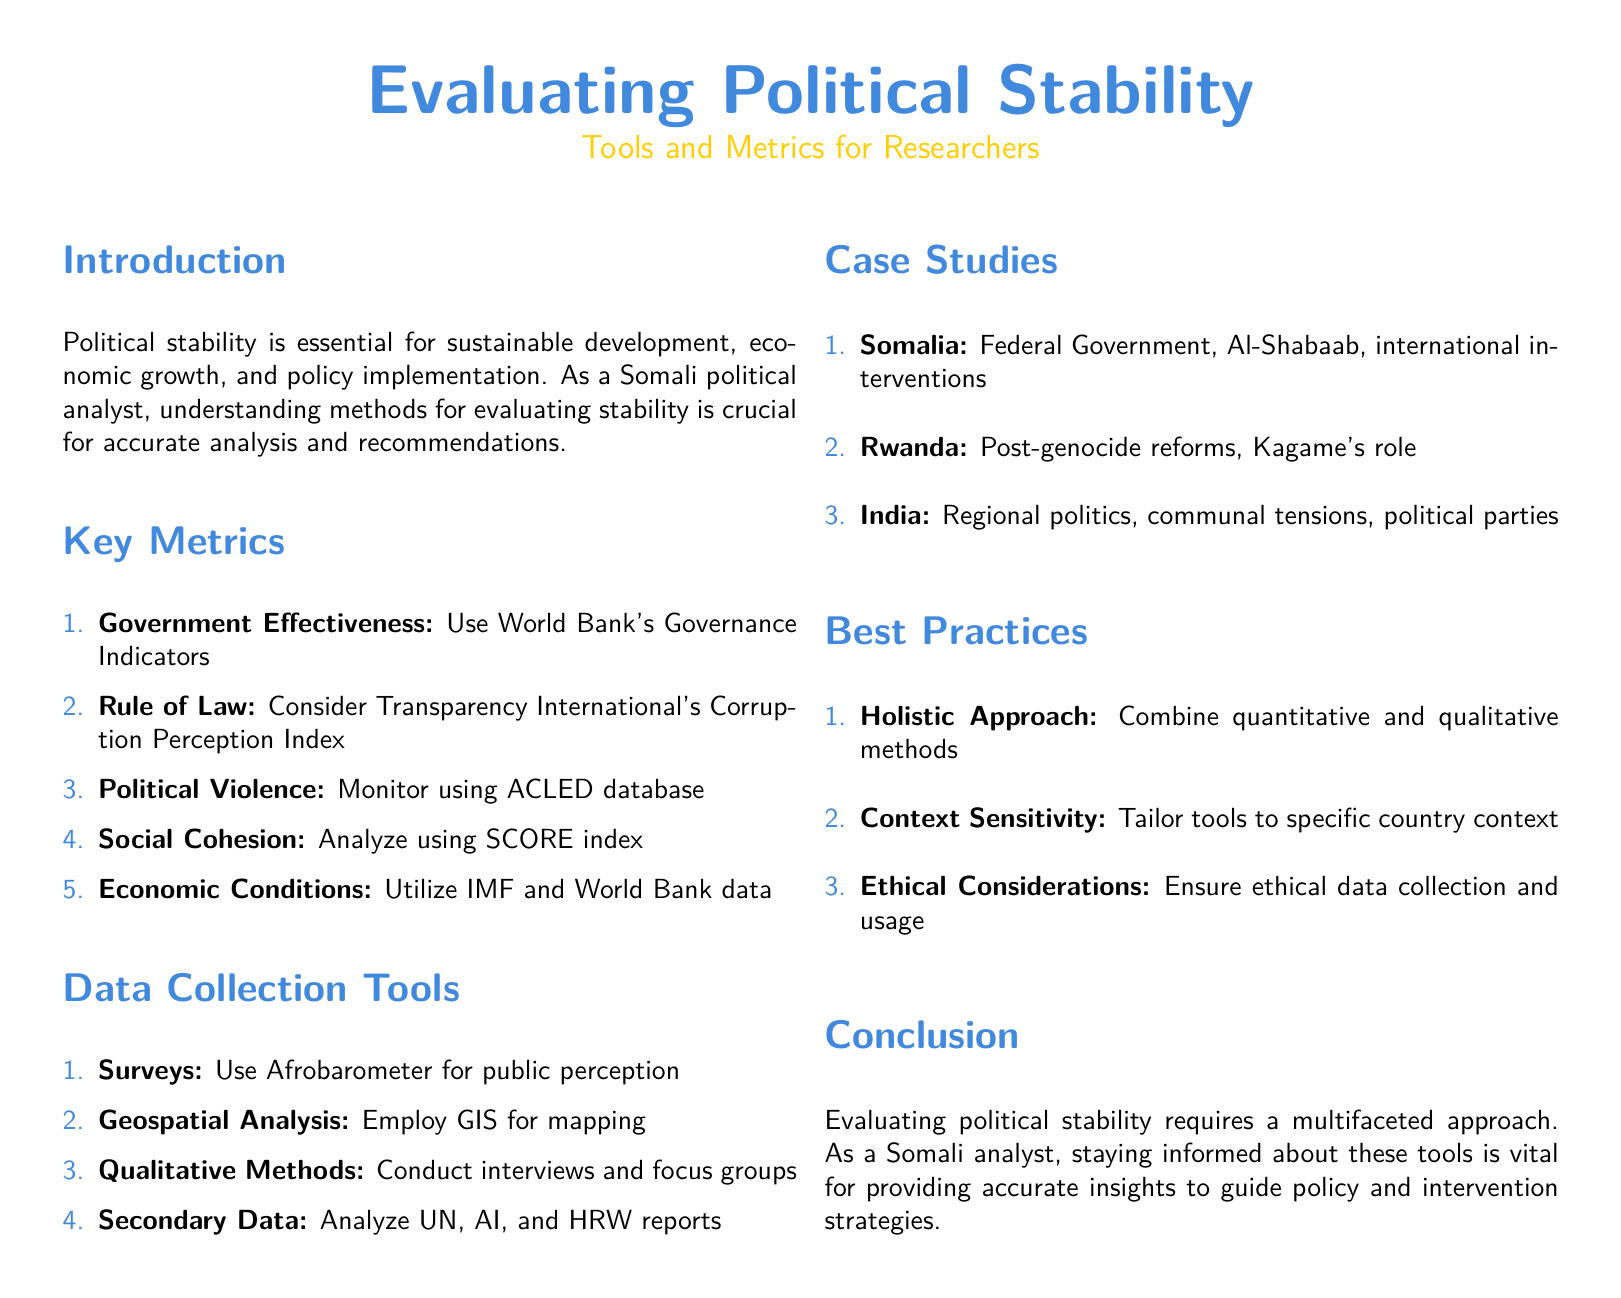What is the title of the document? The title of the document is presented at the top of the first page, which is "Evaluating Political Stability".
Answer: Evaluating Political Stability Which organization provides the Governance Indicators? The document mentions the World Bank as the source for the Governance Indicators.
Answer: World Bank What is the index used to assess corruption perception? The document states that Transparency International's Corruption Perception Index is utilized for this assessment.
Answer: Corruption Perception Index Name one tool used for public perception surveys. The Afrobarometer is listed as a tool for conducting public perception surveys in the data collection tools section.
Answer: Afrobarometer Which case study focuses on political parties? The document specifies India as the case study that addresses the topic of political parties and regional politics.
Answer: India What approach is recommended for evaluating political stability? A holistic approach that combines quantitative and qualitative methods is suggested in the best practices section.
Answer: Holistic Approach What is one ethical consideration mentioned? The document highlights the importance of ensuring ethical data collection and usage as an ethical consideration.
Answer: Ethical Considerations How many key metrics are listed in the document? The document enumerates five key metrics for evaluating political stability.
Answer: Five Which color is used for section headings in the document? The section headings are styled in somali blue, as indicated in the title format configuration.
Answer: somali blue 